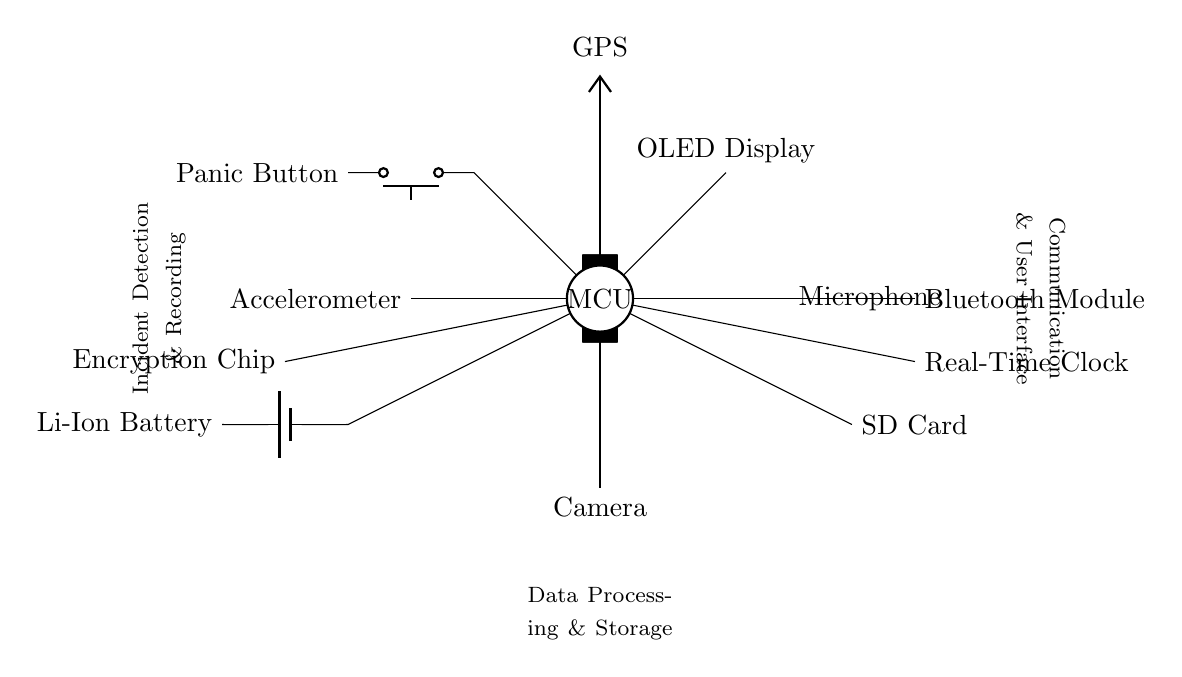What is the primary microcontroller in the circuit? The primary microcontroller is labeled as "MCU" in the circuit diagram. It serves as the central hub for data collection and processing.
Answer: MCU How many sensors are connected to the microcontroller? Four sensors are indicated in the diagram: GPS, Accelerometer, Microphone, and Camera. Each sensor is directly connected to the MCU.
Answer: Four What type of battery is used to power the device? The circuit specifies a "Li-Ion Battery" for power supply, which is a common choice for wearable devices due to its energy density and rechargeability.
Answer: Li-Ion Battery What is the purpose of the Bluetooth module? The Bluetooth module's purpose is to facilitate wireless communication, allowing the device to transmit data to other devices or networks, such as a smartphone or a server.
Answer: Wireless communication Which component is responsible for data encryption? The "Encryption Chip" in the diagram is responsible for ensuring that sensitive data, such as recorded incidents, is securely stored and transmitted.
Answer: Encryption Chip How is incident detection and recording achieved? Incident detection and recording are achieved through integrated sensors (GPS, Accelerometer, Microphone, and Camera) that monitor environmental conditions and user actions, with the data processed by the MCU.
Answer: Sensors and MCU What role does the Real-Time Clock play in the device? The Real-Time Clock helps maintain accurate time, which is crucial for timestamping incident data as it is recorded, ensuring that events can be tracked chronologically.
Answer: Timestamping 